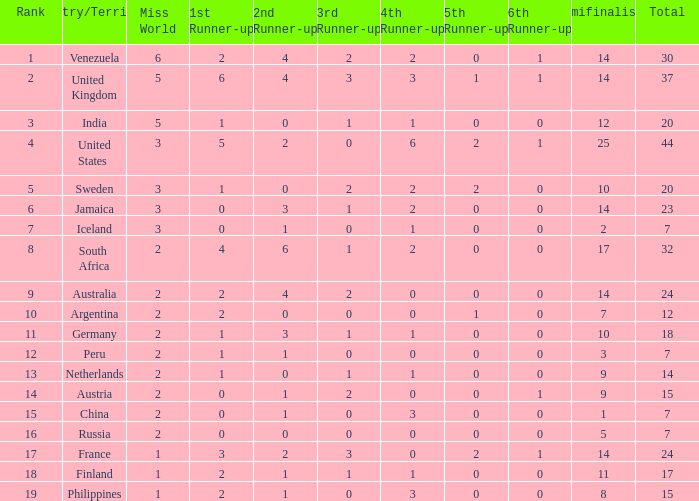What is the United States rank? 1.0. 